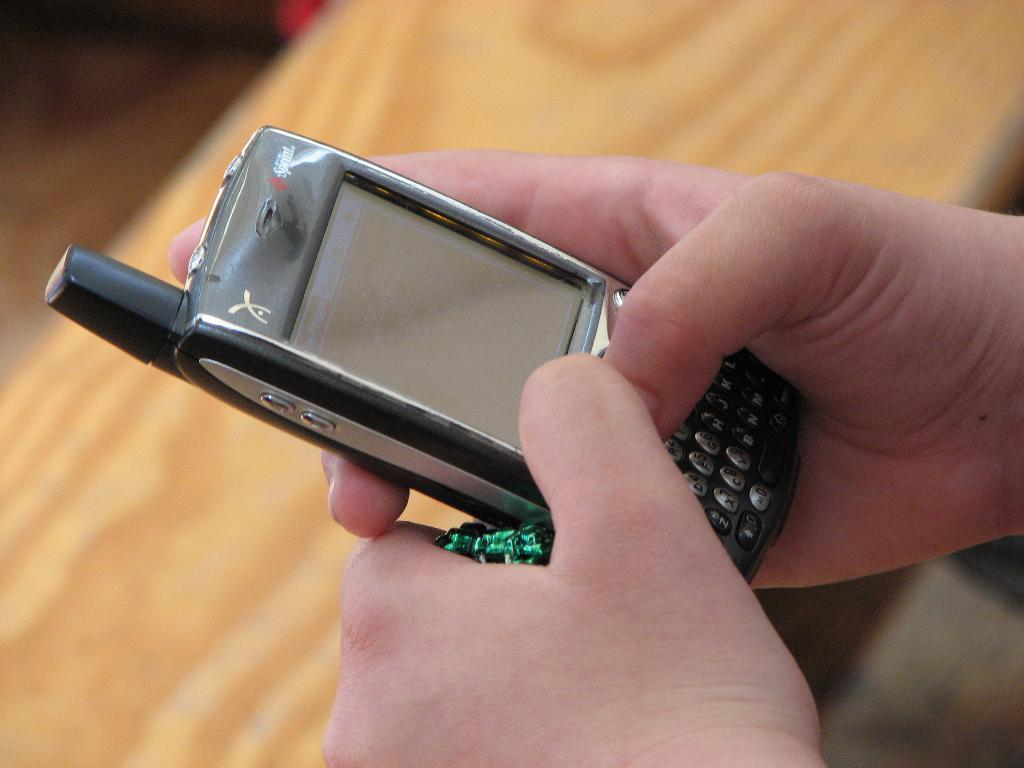What can be seen in the image that is typically used for displaying items? There is a mobile in the image. What color is the object being held by a person in the image? The object being held by a person is green. Who is holding the green object in the image? The green object is being held by a person. How would you describe the background of the image? The background of the image is blurry. What is the person's belief about the company in the image? There is no company or indication of any beliefs in the image; it only features a mobile and a green object being held by a person. 